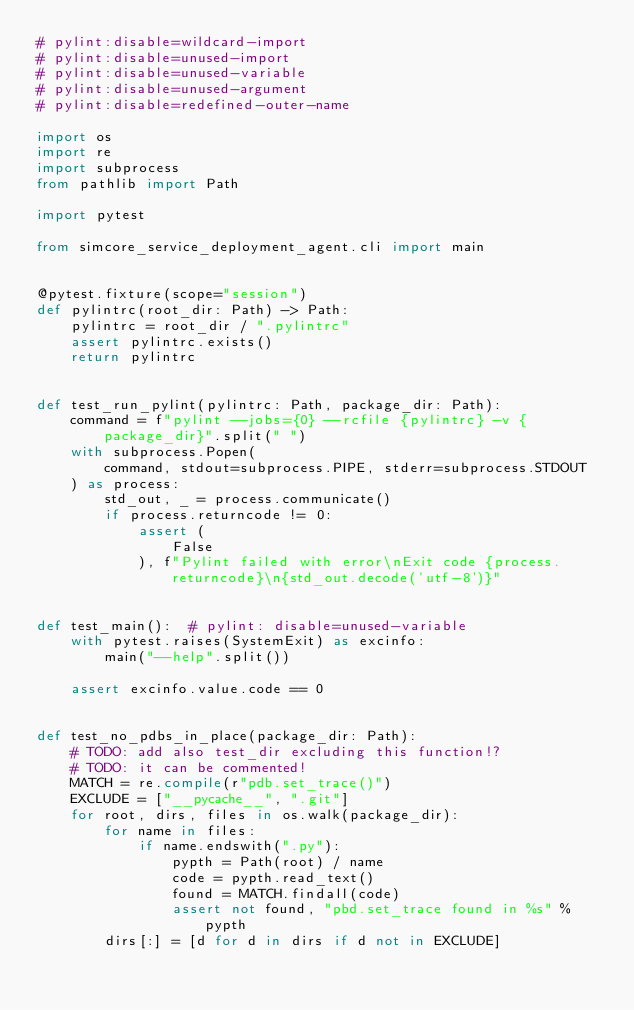<code> <loc_0><loc_0><loc_500><loc_500><_Python_># pylint:disable=wildcard-import
# pylint:disable=unused-import
# pylint:disable=unused-variable
# pylint:disable=unused-argument
# pylint:disable=redefined-outer-name

import os
import re
import subprocess
from pathlib import Path

import pytest

from simcore_service_deployment_agent.cli import main


@pytest.fixture(scope="session")
def pylintrc(root_dir: Path) -> Path:
    pylintrc = root_dir / ".pylintrc"
    assert pylintrc.exists()
    return pylintrc


def test_run_pylint(pylintrc: Path, package_dir: Path):
    command = f"pylint --jobs={0} --rcfile {pylintrc} -v {package_dir}".split(" ")
    with subprocess.Popen(
        command, stdout=subprocess.PIPE, stderr=subprocess.STDOUT
    ) as process:
        std_out, _ = process.communicate()
        if process.returncode != 0:
            assert (
                False
            ), f"Pylint failed with error\nExit code {process.returncode}\n{std_out.decode('utf-8')}"


def test_main():  # pylint: disable=unused-variable
    with pytest.raises(SystemExit) as excinfo:
        main("--help".split())

    assert excinfo.value.code == 0


def test_no_pdbs_in_place(package_dir: Path):
    # TODO: add also test_dir excluding this function!?
    # TODO: it can be commented!
    MATCH = re.compile(r"pdb.set_trace()")
    EXCLUDE = ["__pycache__", ".git"]
    for root, dirs, files in os.walk(package_dir):
        for name in files:
            if name.endswith(".py"):
                pypth = Path(root) / name
                code = pypth.read_text()
                found = MATCH.findall(code)
                assert not found, "pbd.set_trace found in %s" % pypth
        dirs[:] = [d for d in dirs if d not in EXCLUDE]
</code> 